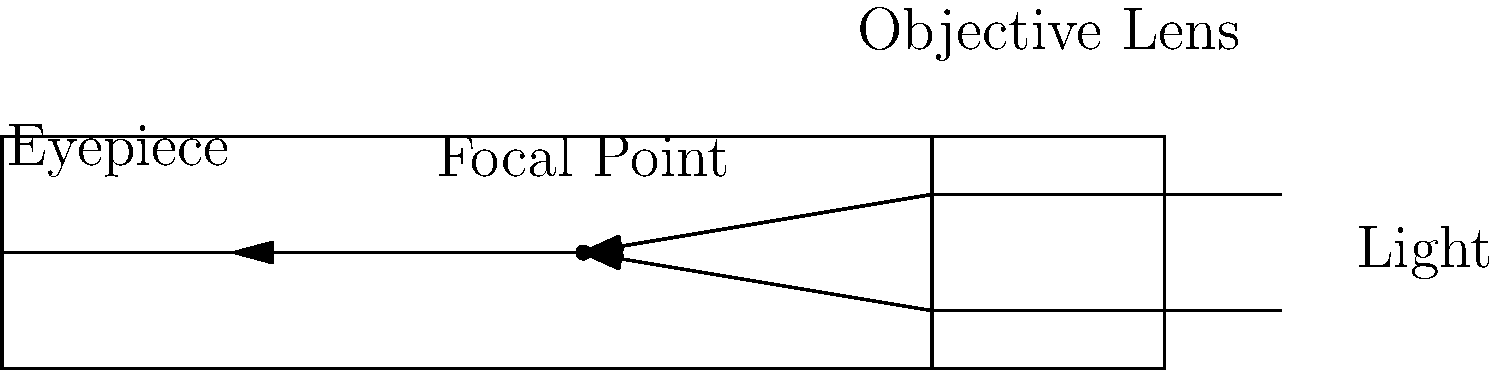In a refracting telescope, which component is responsible for gathering and focusing light from distant objects, and how does it relate to the focal point? To answer this question, let's break down the components and their functions in a refracting telescope:

1. Objective Lens: This is the large lens at the front of the telescope. Its primary function is to gather light from distant objects and focus it to a point within the telescope.

2. Focal Point: This is the point where the light gathered by the objective lens converges. It's located between the objective lens and the eyepiece.

3. Eyepiece: This is the lens through which the observer looks. It magnifies the image formed at the focal point.

In the diagram, we can see that:

a) Light enters the telescope from the right side.
b) The objective lens (labeled at the right end of the telescope) bends the incoming light rays.
c) These bent light rays converge at the focal point (labeled in the middle of the telescope).
d) The light then continues to the eyepiece for the observer to view.

The objective lens is crucial because it determines how much light the telescope can gather. A larger objective lens can collect more light, allowing for observation of fainter objects. The focal length of the objective lens (the distance from the lens to the focal point) also plays a role in determining the telescope's magnification when combined with the eyepiece.

Therefore, the component responsible for gathering and focusing light from distant objects is the objective lens, and it directly creates the focal point where this light converges before reaching the eyepiece.
Answer: Objective lens 